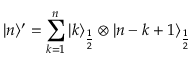Convert formula to latex. <formula><loc_0><loc_0><loc_500><loc_500>| n \rangle ^ { \prime } = \sum _ { k = 1 } ^ { n } | k \rangle _ { \frac { 1 } { 2 } } \otimes | n - k + 1 \rangle _ { \frac { 1 } { 2 } }</formula> 